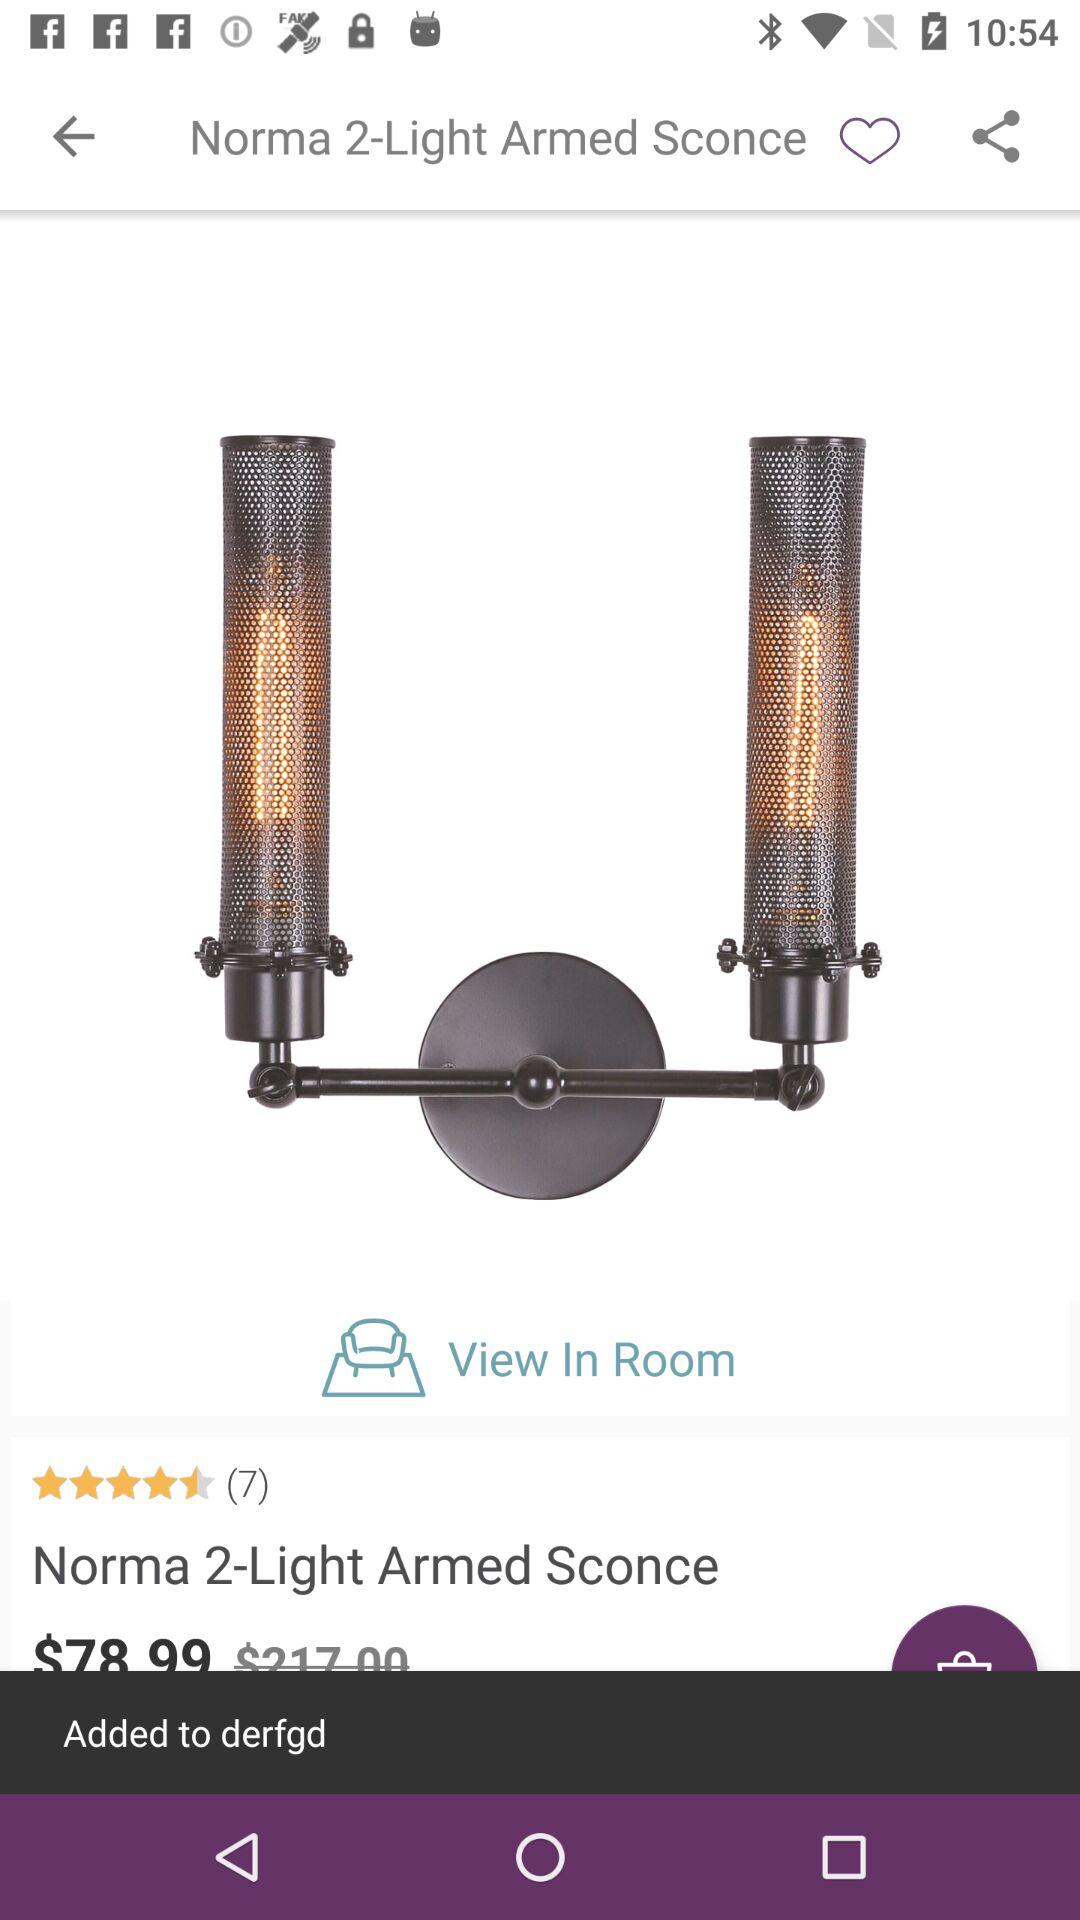What is the star rating? The star rating is 4.5. 